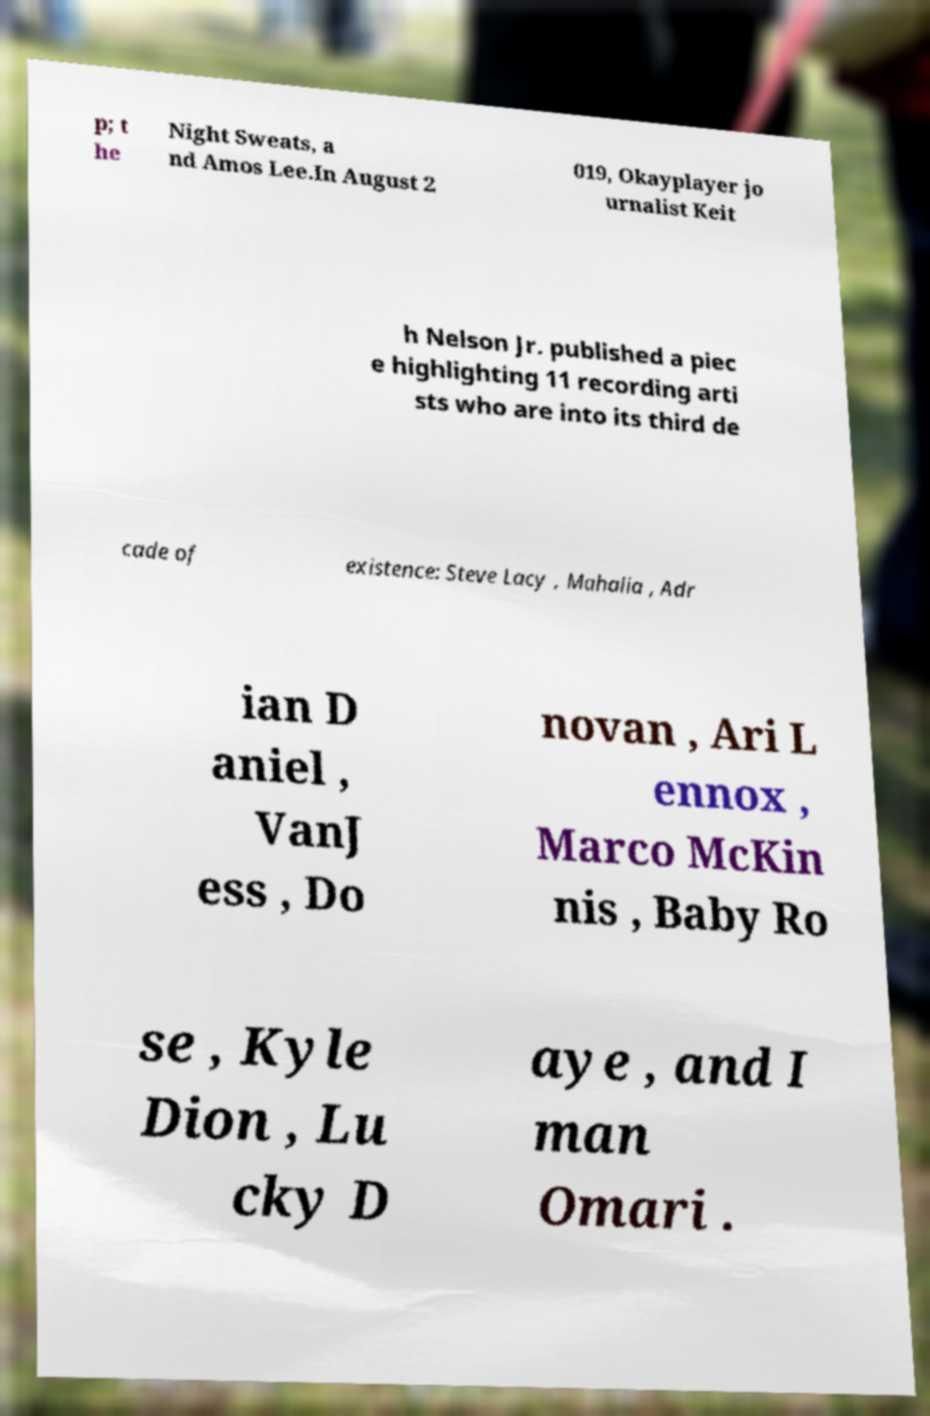There's text embedded in this image that I need extracted. Can you transcribe it verbatim? p; t he Night Sweats, a nd Amos Lee.In August 2 019, Okayplayer jo urnalist Keit h Nelson Jr. published a piec e highlighting 11 recording arti sts who are into its third de cade of existence: Steve Lacy , Mahalia , Adr ian D aniel , VanJ ess , Do novan , Ari L ennox , Marco McKin nis , Baby Ro se , Kyle Dion , Lu cky D aye , and I man Omari . 